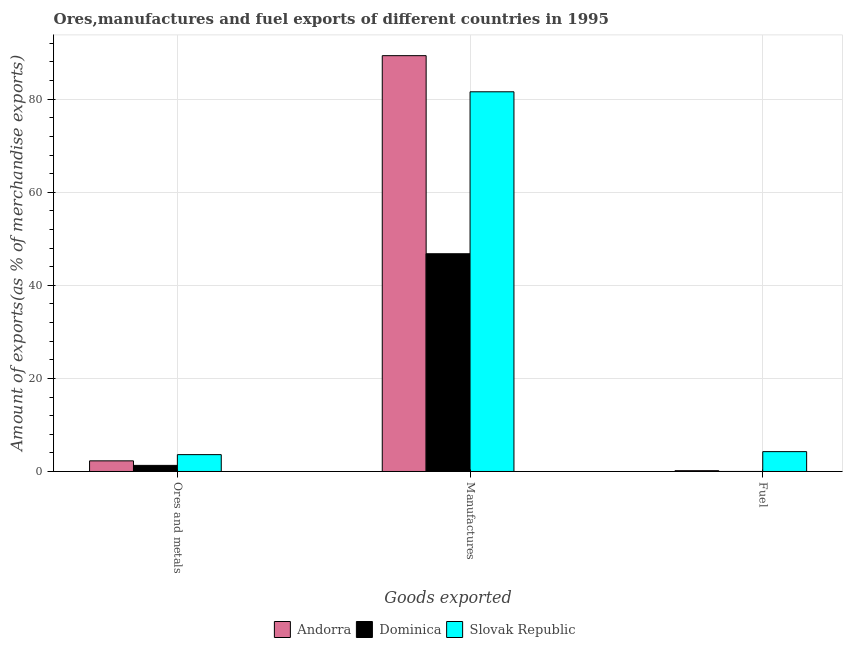How many different coloured bars are there?
Give a very brief answer. 3. How many groups of bars are there?
Make the answer very short. 3. How many bars are there on the 3rd tick from the right?
Your response must be concise. 3. What is the label of the 1st group of bars from the left?
Provide a short and direct response. Ores and metals. What is the percentage of ores and metals exports in Andorra?
Your response must be concise. 2.28. Across all countries, what is the maximum percentage of fuel exports?
Make the answer very short. 4.27. Across all countries, what is the minimum percentage of manufactures exports?
Give a very brief answer. 46.79. In which country was the percentage of fuel exports maximum?
Offer a very short reply. Slovak Republic. In which country was the percentage of manufactures exports minimum?
Your answer should be compact. Dominica. What is the total percentage of ores and metals exports in the graph?
Your answer should be very brief. 7.22. What is the difference between the percentage of manufactures exports in Dominica and that in Andorra?
Provide a succinct answer. -42.56. What is the difference between the percentage of ores and metals exports in Andorra and the percentage of manufactures exports in Dominica?
Give a very brief answer. -44.5. What is the average percentage of ores and metals exports per country?
Offer a very short reply. 2.41. What is the difference between the percentage of fuel exports and percentage of manufactures exports in Slovak Republic?
Your response must be concise. -77.32. In how many countries, is the percentage of fuel exports greater than 72 %?
Offer a very short reply. 0. What is the ratio of the percentage of fuel exports in Andorra to that in Slovak Republic?
Provide a short and direct response. 0.04. Is the difference between the percentage of fuel exports in Slovak Republic and Dominica greater than the difference between the percentage of ores and metals exports in Slovak Republic and Dominica?
Your answer should be very brief. Yes. What is the difference between the highest and the second highest percentage of ores and metals exports?
Your answer should be very brief. 1.34. What is the difference between the highest and the lowest percentage of fuel exports?
Make the answer very short. 4.27. What does the 3rd bar from the left in Ores and metals represents?
Your answer should be very brief. Slovak Republic. What does the 1st bar from the right in Manufactures represents?
Give a very brief answer. Slovak Republic. Is it the case that in every country, the sum of the percentage of ores and metals exports and percentage of manufactures exports is greater than the percentage of fuel exports?
Make the answer very short. Yes. How many countries are there in the graph?
Offer a terse response. 3. How are the legend labels stacked?
Keep it short and to the point. Horizontal. What is the title of the graph?
Ensure brevity in your answer.  Ores,manufactures and fuel exports of different countries in 1995. Does "Madagascar" appear as one of the legend labels in the graph?
Make the answer very short. No. What is the label or title of the X-axis?
Your answer should be very brief. Goods exported. What is the label or title of the Y-axis?
Ensure brevity in your answer.  Amount of exports(as % of merchandise exports). What is the Amount of exports(as % of merchandise exports) in Andorra in Ores and metals?
Keep it short and to the point. 2.28. What is the Amount of exports(as % of merchandise exports) in Dominica in Ores and metals?
Provide a succinct answer. 1.31. What is the Amount of exports(as % of merchandise exports) in Slovak Republic in Ores and metals?
Provide a succinct answer. 3.62. What is the Amount of exports(as % of merchandise exports) of Andorra in Manufactures?
Offer a very short reply. 89.35. What is the Amount of exports(as % of merchandise exports) in Dominica in Manufactures?
Offer a terse response. 46.79. What is the Amount of exports(as % of merchandise exports) in Slovak Republic in Manufactures?
Make the answer very short. 81.59. What is the Amount of exports(as % of merchandise exports) in Andorra in Fuel?
Offer a very short reply. 0.17. What is the Amount of exports(as % of merchandise exports) in Dominica in Fuel?
Provide a succinct answer. 0. What is the Amount of exports(as % of merchandise exports) of Slovak Republic in Fuel?
Keep it short and to the point. 4.27. Across all Goods exported, what is the maximum Amount of exports(as % of merchandise exports) of Andorra?
Your answer should be very brief. 89.35. Across all Goods exported, what is the maximum Amount of exports(as % of merchandise exports) in Dominica?
Keep it short and to the point. 46.79. Across all Goods exported, what is the maximum Amount of exports(as % of merchandise exports) of Slovak Republic?
Ensure brevity in your answer.  81.59. Across all Goods exported, what is the minimum Amount of exports(as % of merchandise exports) of Andorra?
Your response must be concise. 0.17. Across all Goods exported, what is the minimum Amount of exports(as % of merchandise exports) of Dominica?
Give a very brief answer. 0. Across all Goods exported, what is the minimum Amount of exports(as % of merchandise exports) of Slovak Republic?
Offer a very short reply. 3.62. What is the total Amount of exports(as % of merchandise exports) in Andorra in the graph?
Give a very brief answer. 91.81. What is the total Amount of exports(as % of merchandise exports) of Dominica in the graph?
Your answer should be compact. 48.1. What is the total Amount of exports(as % of merchandise exports) of Slovak Republic in the graph?
Your answer should be very brief. 89.47. What is the difference between the Amount of exports(as % of merchandise exports) in Andorra in Ores and metals and that in Manufactures?
Offer a terse response. -87.07. What is the difference between the Amount of exports(as % of merchandise exports) in Dominica in Ores and metals and that in Manufactures?
Provide a succinct answer. -45.48. What is the difference between the Amount of exports(as % of merchandise exports) of Slovak Republic in Ores and metals and that in Manufactures?
Ensure brevity in your answer.  -77.97. What is the difference between the Amount of exports(as % of merchandise exports) in Andorra in Ores and metals and that in Fuel?
Offer a terse response. 2.11. What is the difference between the Amount of exports(as % of merchandise exports) of Dominica in Ores and metals and that in Fuel?
Offer a terse response. 1.31. What is the difference between the Amount of exports(as % of merchandise exports) of Slovak Republic in Ores and metals and that in Fuel?
Provide a short and direct response. -0.65. What is the difference between the Amount of exports(as % of merchandise exports) in Andorra in Manufactures and that in Fuel?
Provide a succinct answer. 89.18. What is the difference between the Amount of exports(as % of merchandise exports) of Dominica in Manufactures and that in Fuel?
Your response must be concise. 46.79. What is the difference between the Amount of exports(as % of merchandise exports) in Slovak Republic in Manufactures and that in Fuel?
Offer a terse response. 77.32. What is the difference between the Amount of exports(as % of merchandise exports) in Andorra in Ores and metals and the Amount of exports(as % of merchandise exports) in Dominica in Manufactures?
Give a very brief answer. -44.5. What is the difference between the Amount of exports(as % of merchandise exports) of Andorra in Ores and metals and the Amount of exports(as % of merchandise exports) of Slovak Republic in Manufactures?
Offer a very short reply. -79.3. What is the difference between the Amount of exports(as % of merchandise exports) of Dominica in Ores and metals and the Amount of exports(as % of merchandise exports) of Slovak Republic in Manufactures?
Make the answer very short. -80.27. What is the difference between the Amount of exports(as % of merchandise exports) of Andorra in Ores and metals and the Amount of exports(as % of merchandise exports) of Dominica in Fuel?
Keep it short and to the point. 2.28. What is the difference between the Amount of exports(as % of merchandise exports) of Andorra in Ores and metals and the Amount of exports(as % of merchandise exports) of Slovak Republic in Fuel?
Keep it short and to the point. -1.98. What is the difference between the Amount of exports(as % of merchandise exports) of Dominica in Ores and metals and the Amount of exports(as % of merchandise exports) of Slovak Republic in Fuel?
Ensure brevity in your answer.  -2.95. What is the difference between the Amount of exports(as % of merchandise exports) in Andorra in Manufactures and the Amount of exports(as % of merchandise exports) in Dominica in Fuel?
Make the answer very short. 89.35. What is the difference between the Amount of exports(as % of merchandise exports) in Andorra in Manufactures and the Amount of exports(as % of merchandise exports) in Slovak Republic in Fuel?
Ensure brevity in your answer.  85.08. What is the difference between the Amount of exports(as % of merchandise exports) in Dominica in Manufactures and the Amount of exports(as % of merchandise exports) in Slovak Republic in Fuel?
Ensure brevity in your answer.  42.52. What is the average Amount of exports(as % of merchandise exports) of Andorra per Goods exported?
Provide a short and direct response. 30.6. What is the average Amount of exports(as % of merchandise exports) in Dominica per Goods exported?
Your response must be concise. 16.03. What is the average Amount of exports(as % of merchandise exports) in Slovak Republic per Goods exported?
Keep it short and to the point. 29.82. What is the difference between the Amount of exports(as % of merchandise exports) in Andorra and Amount of exports(as % of merchandise exports) in Dominica in Ores and metals?
Offer a very short reply. 0.97. What is the difference between the Amount of exports(as % of merchandise exports) of Andorra and Amount of exports(as % of merchandise exports) of Slovak Republic in Ores and metals?
Give a very brief answer. -1.34. What is the difference between the Amount of exports(as % of merchandise exports) of Dominica and Amount of exports(as % of merchandise exports) of Slovak Republic in Ores and metals?
Your response must be concise. -2.31. What is the difference between the Amount of exports(as % of merchandise exports) of Andorra and Amount of exports(as % of merchandise exports) of Dominica in Manufactures?
Keep it short and to the point. 42.56. What is the difference between the Amount of exports(as % of merchandise exports) of Andorra and Amount of exports(as % of merchandise exports) of Slovak Republic in Manufactures?
Your response must be concise. 7.76. What is the difference between the Amount of exports(as % of merchandise exports) of Dominica and Amount of exports(as % of merchandise exports) of Slovak Republic in Manufactures?
Provide a short and direct response. -34.8. What is the difference between the Amount of exports(as % of merchandise exports) of Andorra and Amount of exports(as % of merchandise exports) of Dominica in Fuel?
Your answer should be very brief. 0.17. What is the difference between the Amount of exports(as % of merchandise exports) of Andorra and Amount of exports(as % of merchandise exports) of Slovak Republic in Fuel?
Your answer should be very brief. -4.1. What is the difference between the Amount of exports(as % of merchandise exports) of Dominica and Amount of exports(as % of merchandise exports) of Slovak Republic in Fuel?
Your answer should be very brief. -4.27. What is the ratio of the Amount of exports(as % of merchandise exports) of Andorra in Ores and metals to that in Manufactures?
Offer a very short reply. 0.03. What is the ratio of the Amount of exports(as % of merchandise exports) of Dominica in Ores and metals to that in Manufactures?
Your answer should be very brief. 0.03. What is the ratio of the Amount of exports(as % of merchandise exports) of Slovak Republic in Ores and metals to that in Manufactures?
Provide a short and direct response. 0.04. What is the ratio of the Amount of exports(as % of merchandise exports) in Andorra in Ores and metals to that in Fuel?
Offer a very short reply. 13.34. What is the ratio of the Amount of exports(as % of merchandise exports) in Dominica in Ores and metals to that in Fuel?
Ensure brevity in your answer.  1.22e+04. What is the ratio of the Amount of exports(as % of merchandise exports) in Slovak Republic in Ores and metals to that in Fuel?
Offer a terse response. 0.85. What is the ratio of the Amount of exports(as % of merchandise exports) in Andorra in Manufactures to that in Fuel?
Provide a short and direct response. 521.55. What is the ratio of the Amount of exports(as % of merchandise exports) of Dominica in Manufactures to that in Fuel?
Offer a terse response. 4.35e+05. What is the ratio of the Amount of exports(as % of merchandise exports) in Slovak Republic in Manufactures to that in Fuel?
Provide a succinct answer. 19.12. What is the difference between the highest and the second highest Amount of exports(as % of merchandise exports) of Andorra?
Give a very brief answer. 87.07. What is the difference between the highest and the second highest Amount of exports(as % of merchandise exports) of Dominica?
Your answer should be compact. 45.48. What is the difference between the highest and the second highest Amount of exports(as % of merchandise exports) of Slovak Republic?
Provide a short and direct response. 77.32. What is the difference between the highest and the lowest Amount of exports(as % of merchandise exports) in Andorra?
Provide a succinct answer. 89.18. What is the difference between the highest and the lowest Amount of exports(as % of merchandise exports) of Dominica?
Your answer should be compact. 46.79. What is the difference between the highest and the lowest Amount of exports(as % of merchandise exports) of Slovak Republic?
Your answer should be compact. 77.97. 